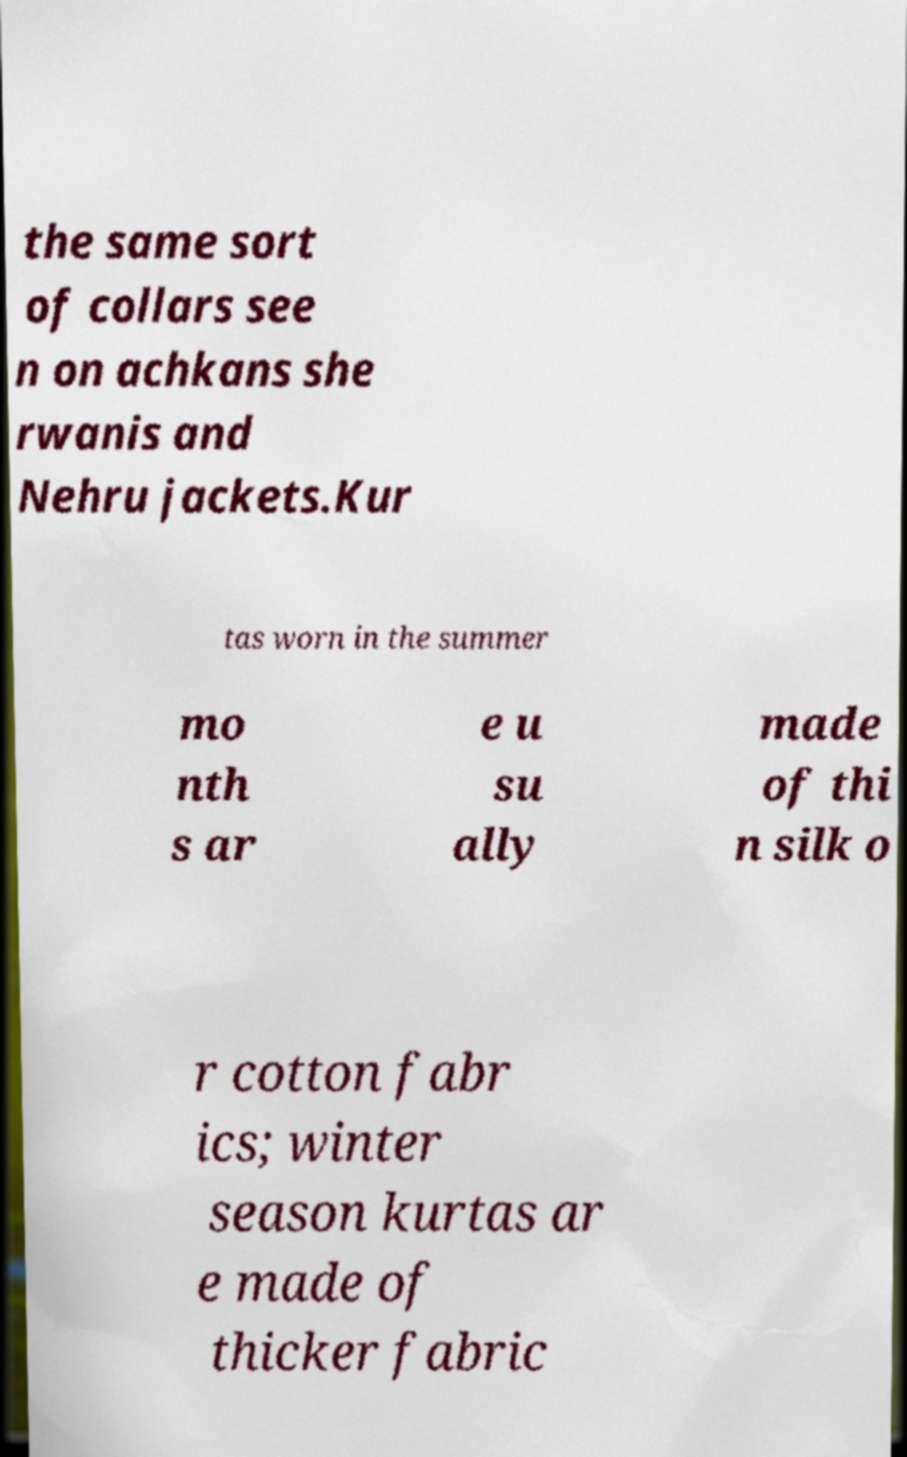Could you extract and type out the text from this image? the same sort of collars see n on achkans she rwanis and Nehru jackets.Kur tas worn in the summer mo nth s ar e u su ally made of thi n silk o r cotton fabr ics; winter season kurtas ar e made of thicker fabric 